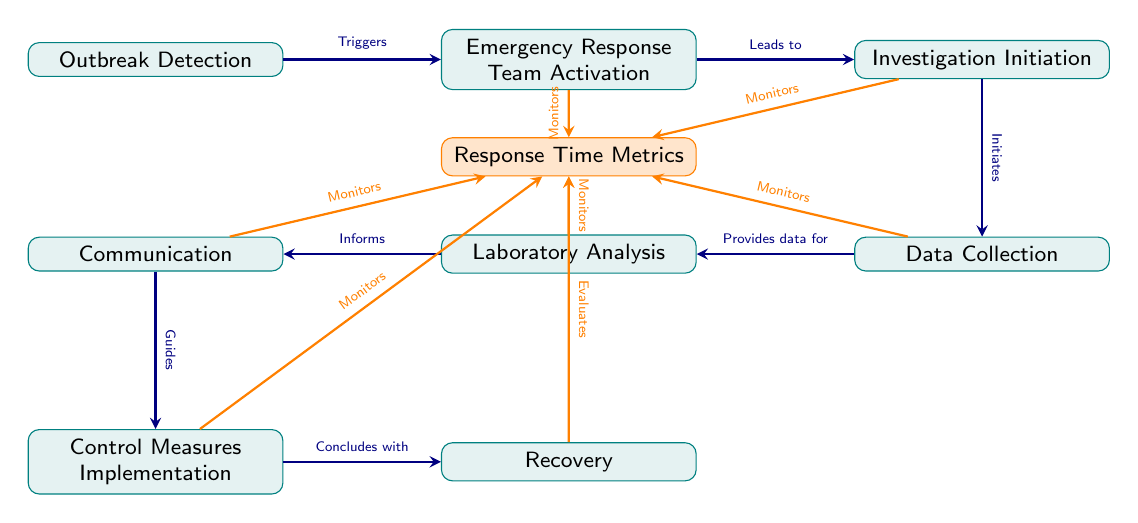What is the first step in the outbreak containment plan? The first step in the diagram is labeled "Outbreak Detection," indicating it is the initial action needed to address a foodborne illness outbreak.
Answer: Outbreak Detection How many nodes are present in the diagram? The diagram contains a total of eight nodes including the "Response Time Metrics," which tracks metrics pertaining to the entire process, thus the total is nine.
Answer: Nine What action follows the activation of the Emergency Response Team? The diagram shows that the action directly following "Emergency Response Team Activation" is "Investigation Initiation," illustrating the sequence of actions following the team's activation.
Answer: Investigation Initiation What role does laboratory analysis play in the containment plan? The "Laboratory Analysis" node informs the "Communication" node, indicating that findings from the analysis are critical for communicating necessary information during the outbreak containment process.
Answer: Informs Which nodes monitor the Response Time Metrics? According to the diagram, the nodes that monitor "Response Time Metrics" include "Emergency Response Team Activation," "Investigation Initiation," "Data Collection," "Laboratory Analysis," "Communication," and "Control Measures Implementation." This indicates that various stages are tracked to ensure timely responses to an outbreak.
Answer: Emergency Response Team Activation, Investigation Initiation, Data Collection, Laboratory Analysis, Communication, Control Measures Implementation What is the last step in the outbreak containment process? The final step, as indicated by the flow of the diagram, is labeled as "Recovery," concluding the outbreak response plan.
Answer: Recovery Which node evaluates the Response Time Metrics? The diagram specifies that the "Recovery" node evaluates the "Response Time Metrics," showing that the effectiveness of the response can be assessed after the recovery phase.
Answer: Recovery 